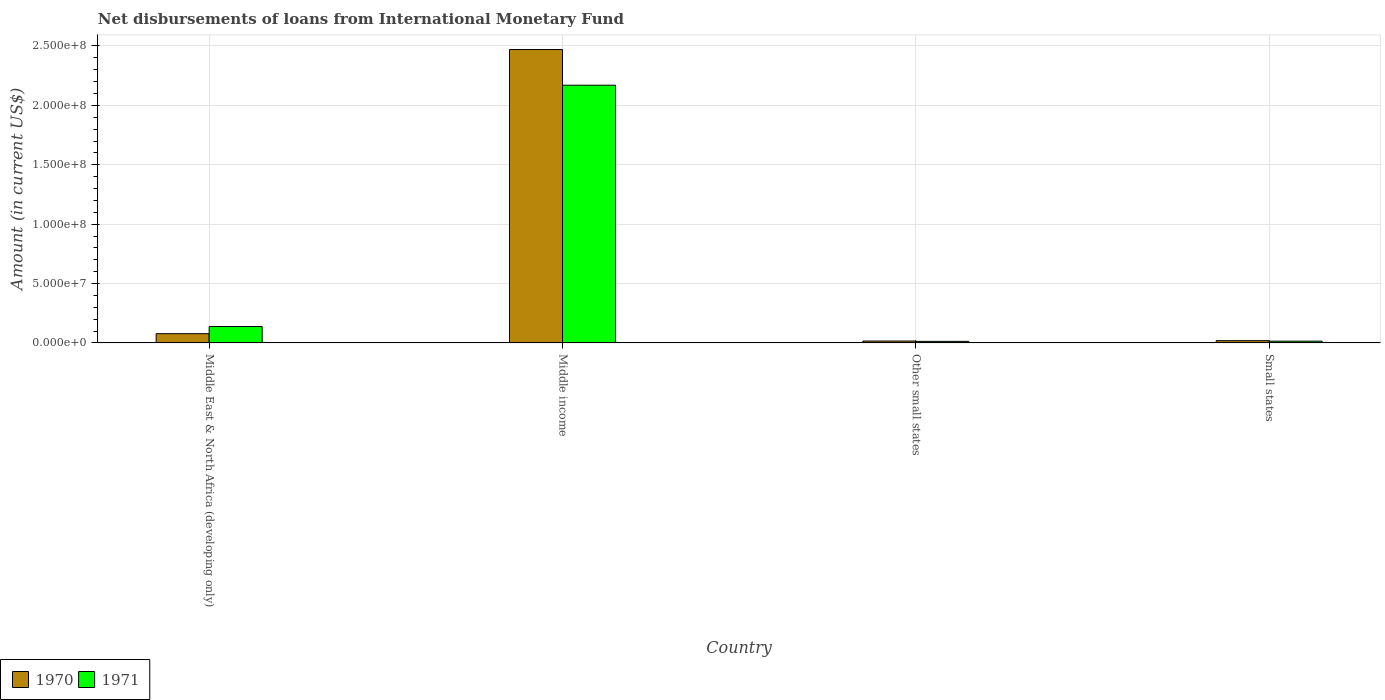How many different coloured bars are there?
Give a very brief answer. 2. Are the number of bars per tick equal to the number of legend labels?
Give a very brief answer. Yes. Are the number of bars on each tick of the X-axis equal?
Your response must be concise. Yes. What is the label of the 3rd group of bars from the left?
Provide a succinct answer. Other small states. What is the amount of loans disbursed in 1970 in Small states?
Your answer should be compact. 1.91e+06. Across all countries, what is the maximum amount of loans disbursed in 1970?
Ensure brevity in your answer.  2.47e+08. Across all countries, what is the minimum amount of loans disbursed in 1971?
Your answer should be very brief. 1.32e+06. In which country was the amount of loans disbursed in 1970 minimum?
Offer a very short reply. Other small states. What is the total amount of loans disbursed in 1970 in the graph?
Offer a terse response. 2.58e+08. What is the difference between the amount of loans disbursed in 1970 in Middle East & North Africa (developing only) and that in Small states?
Provide a succinct answer. 5.89e+06. What is the difference between the amount of loans disbursed in 1970 in Other small states and the amount of loans disbursed in 1971 in Small states?
Your answer should be compact. 1.09e+05. What is the average amount of loans disbursed in 1970 per country?
Your response must be concise. 6.46e+07. What is the difference between the amount of loans disbursed of/in 1971 and amount of loans disbursed of/in 1970 in Small states?
Make the answer very short. -4.08e+05. In how many countries, is the amount of loans disbursed in 1971 greater than 170000000 US$?
Your response must be concise. 1. What is the ratio of the amount of loans disbursed in 1970 in Middle East & North Africa (developing only) to that in Middle income?
Provide a succinct answer. 0.03. Is the amount of loans disbursed in 1971 in Middle East & North Africa (developing only) less than that in Small states?
Ensure brevity in your answer.  No. Is the difference between the amount of loans disbursed in 1971 in Middle East & North Africa (developing only) and Other small states greater than the difference between the amount of loans disbursed in 1970 in Middle East & North Africa (developing only) and Other small states?
Offer a very short reply. Yes. What is the difference between the highest and the second highest amount of loans disbursed in 1971?
Your answer should be compact. 2.03e+08. What is the difference between the highest and the lowest amount of loans disbursed in 1971?
Ensure brevity in your answer.  2.16e+08. Is the sum of the amount of loans disbursed in 1971 in Middle East & North Africa (developing only) and Middle income greater than the maximum amount of loans disbursed in 1970 across all countries?
Provide a short and direct response. No. What does the 1st bar from the left in Other small states represents?
Offer a very short reply. 1970. Are all the bars in the graph horizontal?
Ensure brevity in your answer.  No. What is the difference between two consecutive major ticks on the Y-axis?
Your response must be concise. 5.00e+07. Does the graph contain any zero values?
Your answer should be very brief. No. Does the graph contain grids?
Provide a succinct answer. Yes. What is the title of the graph?
Provide a succinct answer. Net disbursements of loans from International Monetary Fund. Does "1996" appear as one of the legend labels in the graph?
Ensure brevity in your answer.  No. What is the label or title of the Y-axis?
Give a very brief answer. Amount (in current US$). What is the Amount (in current US$) in 1970 in Middle East & North Africa (developing only)?
Your answer should be compact. 7.79e+06. What is the Amount (in current US$) in 1971 in Middle East & North Africa (developing only)?
Offer a very short reply. 1.38e+07. What is the Amount (in current US$) in 1970 in Middle income?
Offer a very short reply. 2.47e+08. What is the Amount (in current US$) in 1971 in Middle income?
Offer a terse response. 2.17e+08. What is the Amount (in current US$) in 1970 in Other small states?
Make the answer very short. 1.61e+06. What is the Amount (in current US$) of 1971 in Other small states?
Provide a succinct answer. 1.32e+06. What is the Amount (in current US$) of 1970 in Small states?
Offer a very short reply. 1.91e+06. What is the Amount (in current US$) in 1971 in Small states?
Keep it short and to the point. 1.50e+06. Across all countries, what is the maximum Amount (in current US$) in 1970?
Keep it short and to the point. 2.47e+08. Across all countries, what is the maximum Amount (in current US$) of 1971?
Your answer should be very brief. 2.17e+08. Across all countries, what is the minimum Amount (in current US$) in 1970?
Make the answer very short. 1.61e+06. Across all countries, what is the minimum Amount (in current US$) in 1971?
Provide a short and direct response. 1.32e+06. What is the total Amount (in current US$) of 1970 in the graph?
Your response must be concise. 2.58e+08. What is the total Amount (in current US$) of 1971 in the graph?
Provide a succinct answer. 2.34e+08. What is the difference between the Amount (in current US$) in 1970 in Middle East & North Africa (developing only) and that in Middle income?
Offer a very short reply. -2.39e+08. What is the difference between the Amount (in current US$) in 1971 in Middle East & North Africa (developing only) and that in Middle income?
Your response must be concise. -2.03e+08. What is the difference between the Amount (in current US$) of 1970 in Middle East & North Africa (developing only) and that in Other small states?
Offer a terse response. 6.19e+06. What is the difference between the Amount (in current US$) of 1971 in Middle East & North Africa (developing only) and that in Other small states?
Ensure brevity in your answer.  1.25e+07. What is the difference between the Amount (in current US$) in 1970 in Middle East & North Africa (developing only) and that in Small states?
Provide a succinct answer. 5.89e+06. What is the difference between the Amount (in current US$) in 1971 in Middle East & North Africa (developing only) and that in Small states?
Your response must be concise. 1.23e+07. What is the difference between the Amount (in current US$) in 1970 in Middle income and that in Other small states?
Offer a terse response. 2.45e+08. What is the difference between the Amount (in current US$) in 1971 in Middle income and that in Other small states?
Your response must be concise. 2.16e+08. What is the difference between the Amount (in current US$) in 1970 in Middle income and that in Small states?
Ensure brevity in your answer.  2.45e+08. What is the difference between the Amount (in current US$) in 1971 in Middle income and that in Small states?
Make the answer very short. 2.15e+08. What is the difference between the Amount (in current US$) in 1970 in Other small states and that in Small states?
Provide a short and direct response. -2.99e+05. What is the difference between the Amount (in current US$) in 1971 in Other small states and that in Small states?
Your answer should be very brief. -1.76e+05. What is the difference between the Amount (in current US$) in 1970 in Middle East & North Africa (developing only) and the Amount (in current US$) in 1971 in Middle income?
Ensure brevity in your answer.  -2.09e+08. What is the difference between the Amount (in current US$) in 1970 in Middle East & North Africa (developing only) and the Amount (in current US$) in 1971 in Other small states?
Make the answer very short. 6.47e+06. What is the difference between the Amount (in current US$) of 1970 in Middle East & North Africa (developing only) and the Amount (in current US$) of 1971 in Small states?
Provide a succinct answer. 6.30e+06. What is the difference between the Amount (in current US$) in 1970 in Middle income and the Amount (in current US$) in 1971 in Other small states?
Offer a very short reply. 2.46e+08. What is the difference between the Amount (in current US$) in 1970 in Middle income and the Amount (in current US$) in 1971 in Small states?
Provide a succinct answer. 2.46e+08. What is the difference between the Amount (in current US$) in 1970 in Other small states and the Amount (in current US$) in 1971 in Small states?
Offer a terse response. 1.09e+05. What is the average Amount (in current US$) in 1970 per country?
Provide a succinct answer. 6.46e+07. What is the average Amount (in current US$) in 1971 per country?
Provide a short and direct response. 5.84e+07. What is the difference between the Amount (in current US$) in 1970 and Amount (in current US$) in 1971 in Middle East & North Africa (developing only)?
Your response must be concise. -6.03e+06. What is the difference between the Amount (in current US$) of 1970 and Amount (in current US$) of 1971 in Middle income?
Provide a short and direct response. 3.00e+07. What is the difference between the Amount (in current US$) of 1970 and Amount (in current US$) of 1971 in Other small states?
Your answer should be compact. 2.85e+05. What is the difference between the Amount (in current US$) in 1970 and Amount (in current US$) in 1971 in Small states?
Keep it short and to the point. 4.08e+05. What is the ratio of the Amount (in current US$) in 1970 in Middle East & North Africa (developing only) to that in Middle income?
Provide a succinct answer. 0.03. What is the ratio of the Amount (in current US$) in 1971 in Middle East & North Africa (developing only) to that in Middle income?
Your response must be concise. 0.06. What is the ratio of the Amount (in current US$) of 1970 in Middle East & North Africa (developing only) to that in Other small states?
Provide a succinct answer. 4.85. What is the ratio of the Amount (in current US$) of 1971 in Middle East & North Africa (developing only) to that in Other small states?
Offer a terse response. 10.45. What is the ratio of the Amount (in current US$) in 1970 in Middle East & North Africa (developing only) to that in Small states?
Make the answer very short. 4.09. What is the ratio of the Amount (in current US$) of 1971 in Middle East & North Africa (developing only) to that in Small states?
Provide a succinct answer. 9.23. What is the ratio of the Amount (in current US$) of 1970 in Middle income to that in Other small states?
Offer a very short reply. 153.71. What is the ratio of the Amount (in current US$) in 1971 in Middle income to that in Other small states?
Your response must be concise. 164.14. What is the ratio of the Amount (in current US$) in 1970 in Middle income to that in Small states?
Keep it short and to the point. 129.6. What is the ratio of the Amount (in current US$) of 1971 in Middle income to that in Small states?
Keep it short and to the point. 144.85. What is the ratio of the Amount (in current US$) of 1970 in Other small states to that in Small states?
Your response must be concise. 0.84. What is the ratio of the Amount (in current US$) in 1971 in Other small states to that in Small states?
Keep it short and to the point. 0.88. What is the difference between the highest and the second highest Amount (in current US$) of 1970?
Offer a very short reply. 2.39e+08. What is the difference between the highest and the second highest Amount (in current US$) of 1971?
Provide a succinct answer. 2.03e+08. What is the difference between the highest and the lowest Amount (in current US$) of 1970?
Keep it short and to the point. 2.45e+08. What is the difference between the highest and the lowest Amount (in current US$) of 1971?
Make the answer very short. 2.16e+08. 